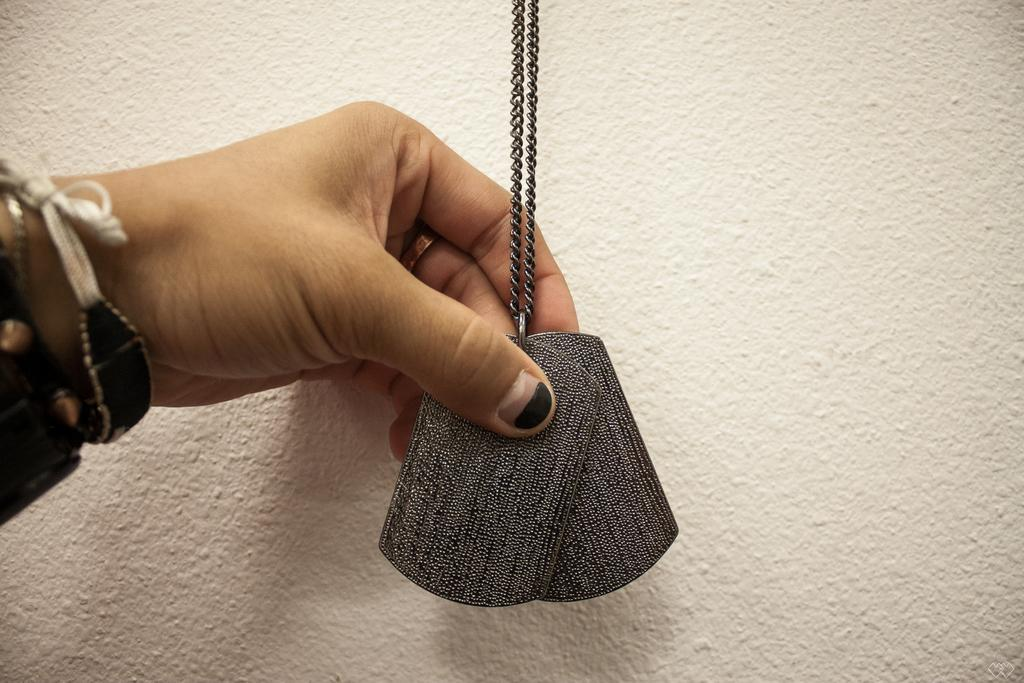What is the person holding in the image? A person's hand is holding a chain and locket in the image. What can be seen in the background of the image? There is a white background in the image, which might be a wall. Where is the drawer located in the image? There is no drawer present in the image; it only shows a person's hand holding a chain and locket against a white background. 